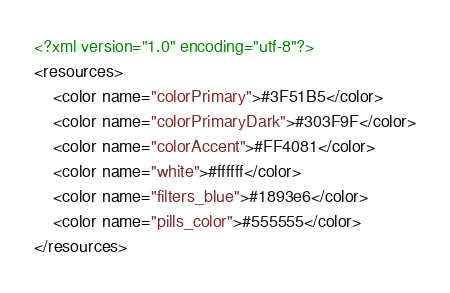Convert code to text. <code><loc_0><loc_0><loc_500><loc_500><_XML_><?xml version="1.0" encoding="utf-8"?>
<resources>
    <color name="colorPrimary">#3F51B5</color>
    <color name="colorPrimaryDark">#303F9F</color>
    <color name="colorAccent">#FF4081</color>
    <color name="white">#ffffff</color>
    <color name="filters_blue">#1893e6</color>
    <color name="pills_color">#555555</color>
</resources>
</code> 